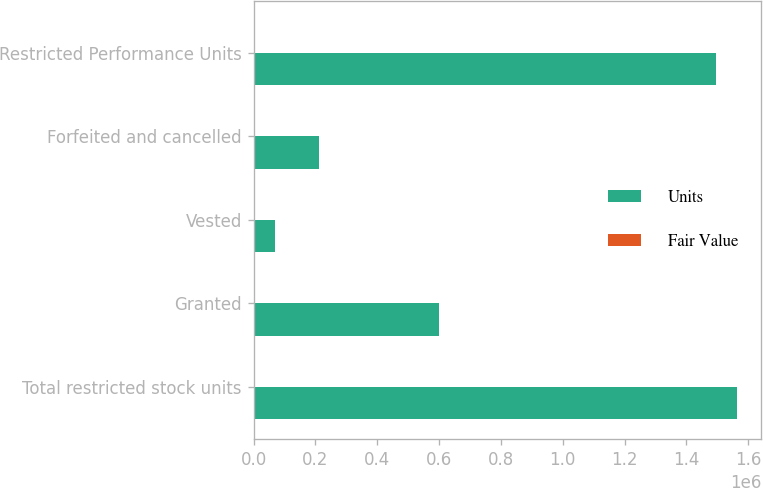Convert chart to OTSL. <chart><loc_0><loc_0><loc_500><loc_500><stacked_bar_chart><ecel><fcel>Total restricted stock units<fcel>Granted<fcel>Vested<fcel>Forfeited and cancelled<fcel>Restricted Performance Units<nl><fcel>Units<fcel>1.56433e+06<fcel>600000<fcel>69875<fcel>212077<fcel>1.49446e+06<nl><fcel>Fair Value<fcel>23<fcel>18.15<fcel>31.36<fcel>23.77<fcel>22.61<nl></chart> 